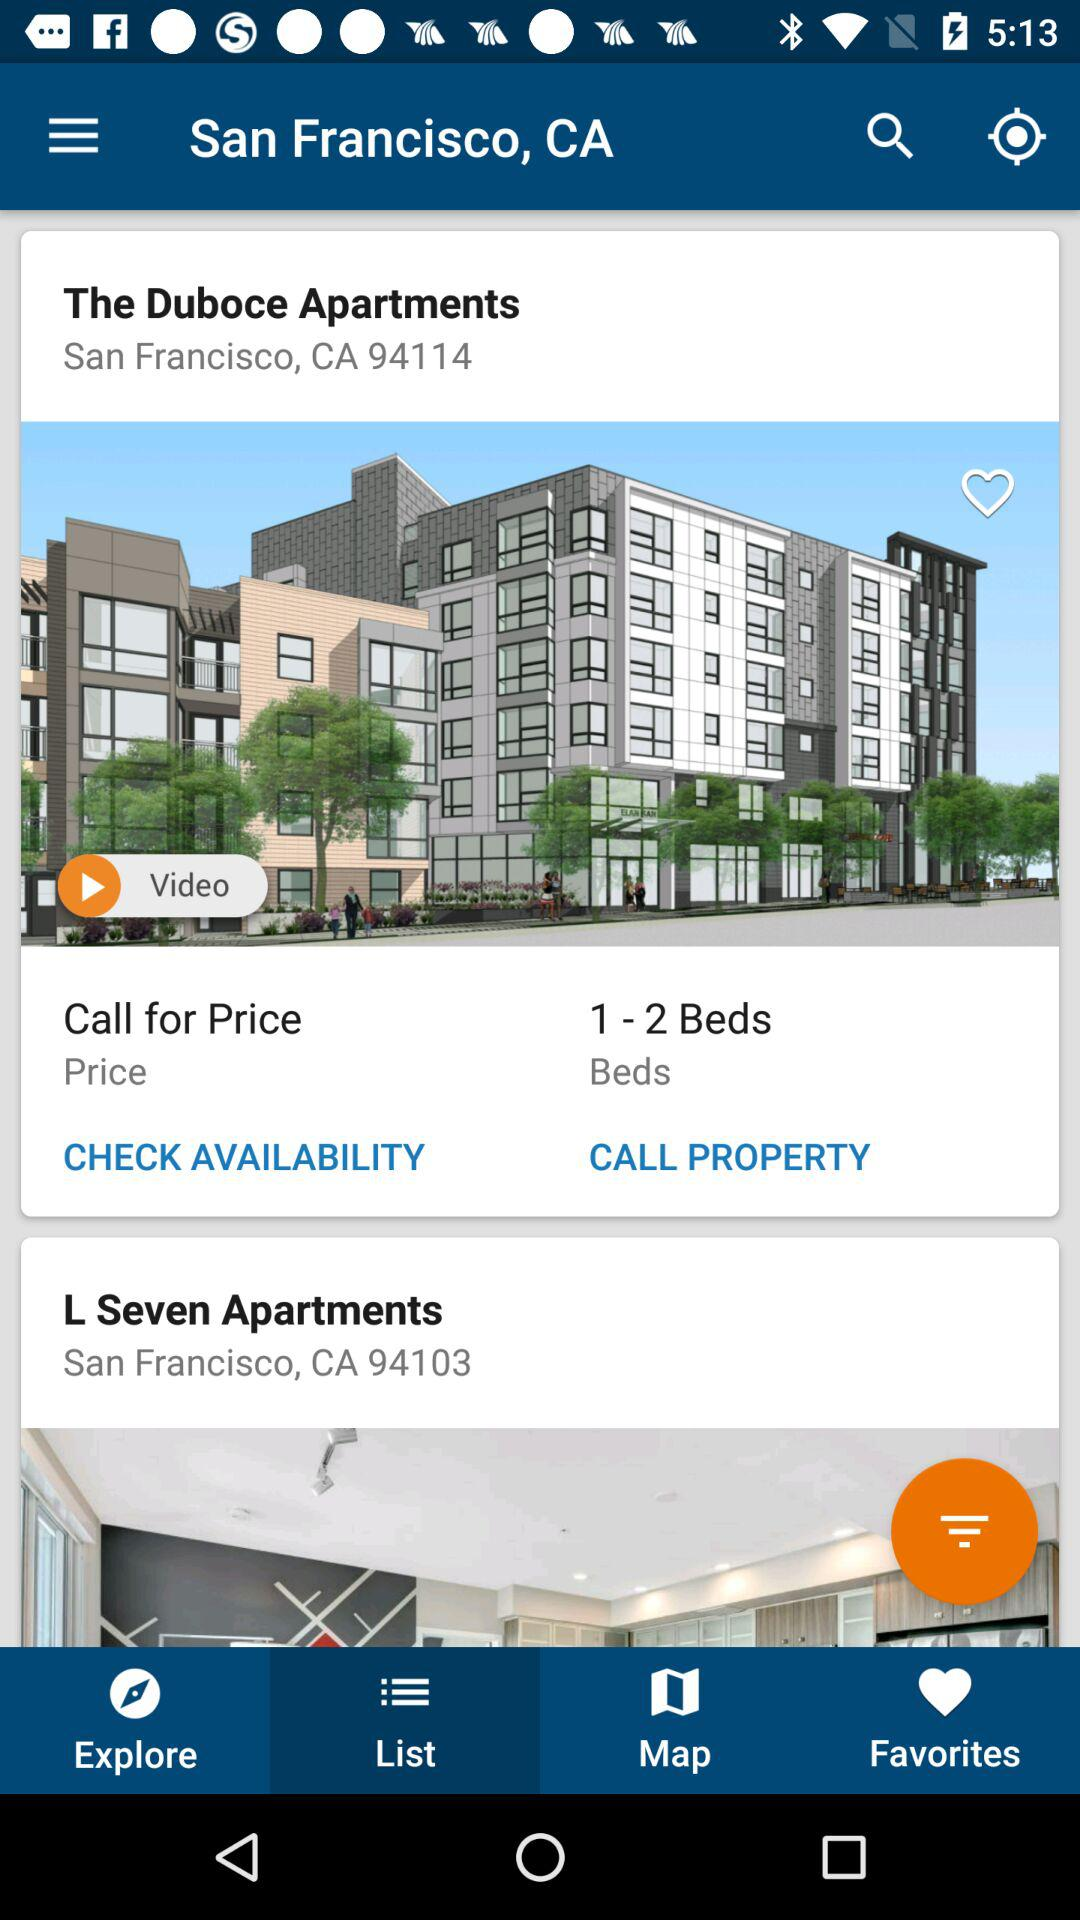Which tab is selected? The selected tab is "List". 